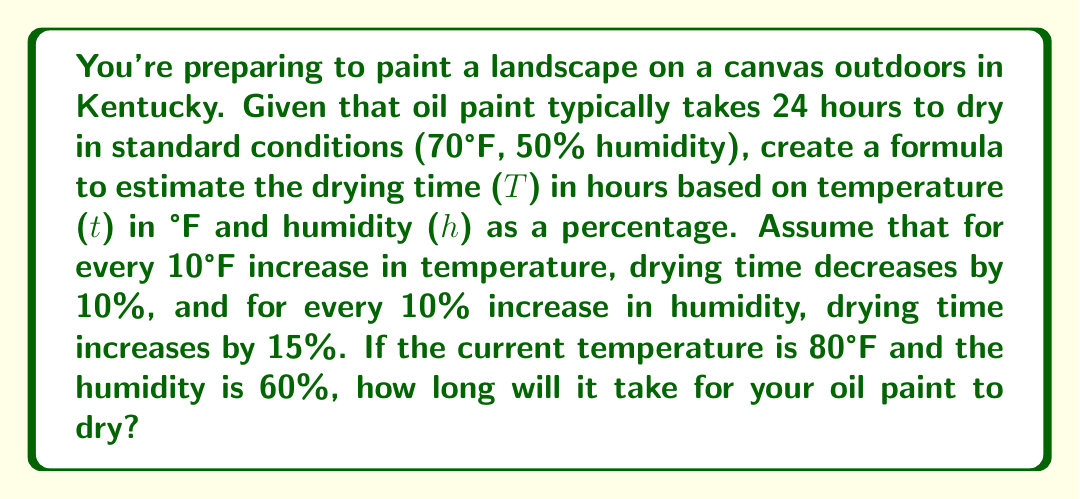Give your solution to this math problem. Let's approach this step-by-step:

1) First, we need to create a formula for the drying time T based on temperature t and humidity h:

   $$ T = 24 \cdot (1 - 0.01(t-70)) \cdot (1 + 0.015(h-50)) $$

   Where 24 is the standard drying time in hours, (1 - 0.01(t-70)) accounts for temperature changes, and (1 + 0.015(h-50)) accounts for humidity changes.

2) Now, let's plug in the given values: t = 80°F and h = 60%

   $$ T = 24 \cdot (1 - 0.01(80-70)) \cdot (1 + 0.015(60-50)) $$

3) Simplify the temperature factor:
   $$ (1 - 0.01(80-70)) = (1 - 0.01(10)) = (1 - 0.1) = 0.9 $$

4) Simplify the humidity factor:
   $$ (1 + 0.015(60-50)) = (1 + 0.015(10)) = (1 + 0.15) = 1.15 $$

5) Now our equation looks like this:
   $$ T = 24 \cdot 0.9 \cdot 1.15 $$

6) Multiply:
   $$ T = 24 \cdot 1.035 = 24.84 $$

Therefore, it will take approximately 24.84 hours for the oil paint to dry in these conditions.
Answer: 24.84 hours 